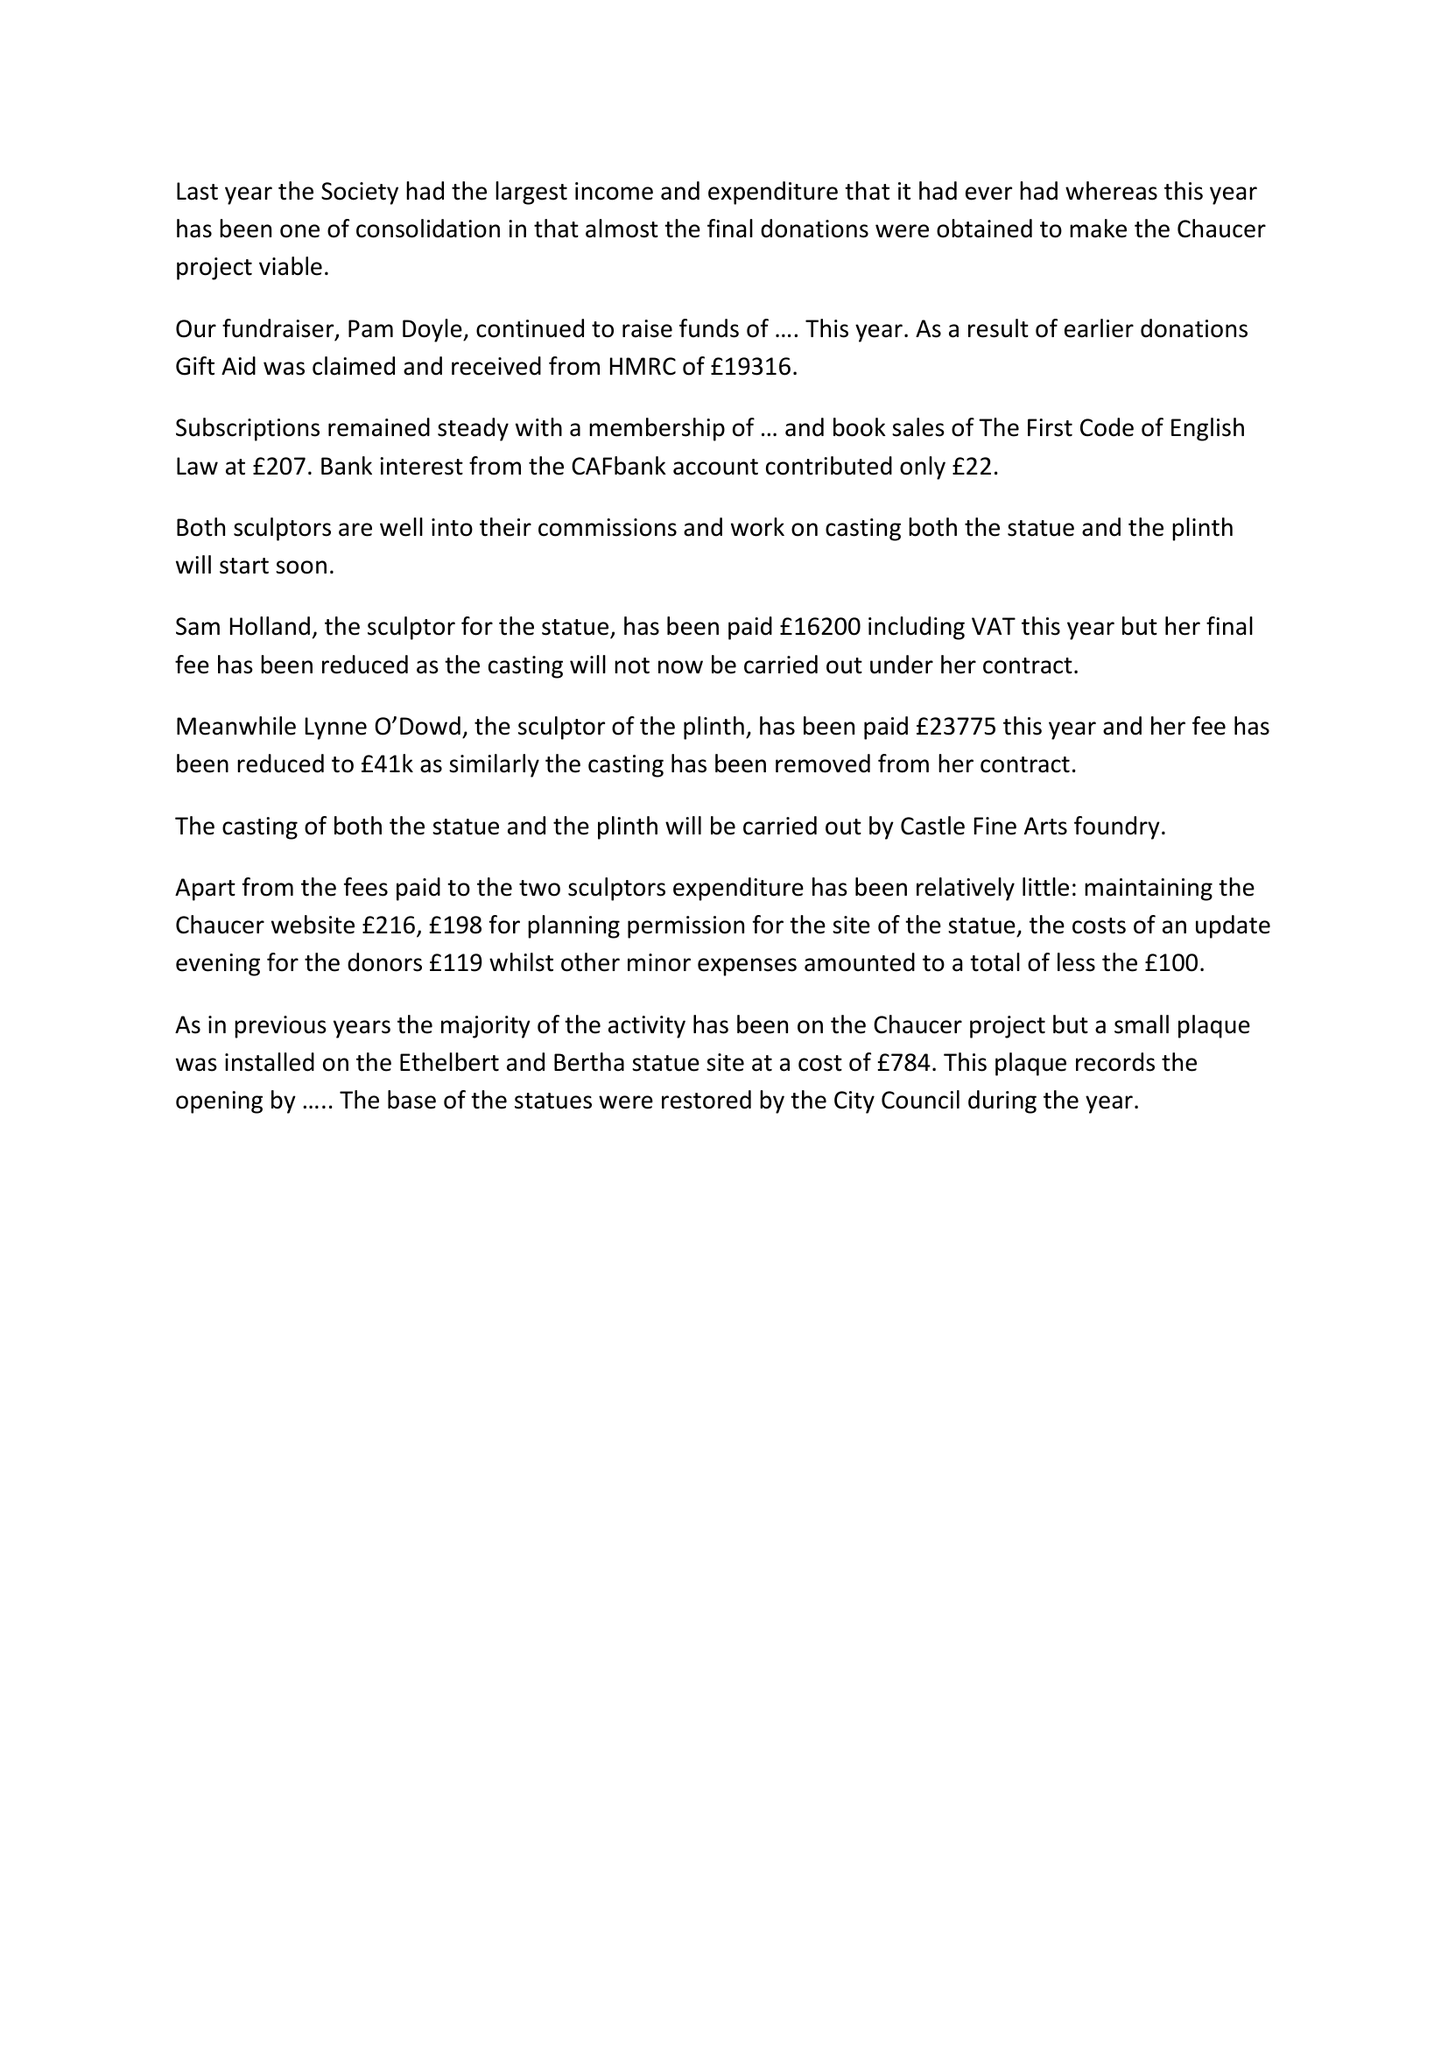What is the value for the charity_name?
Answer the question using a single word or phrase. Canterbury Commemoration Society 